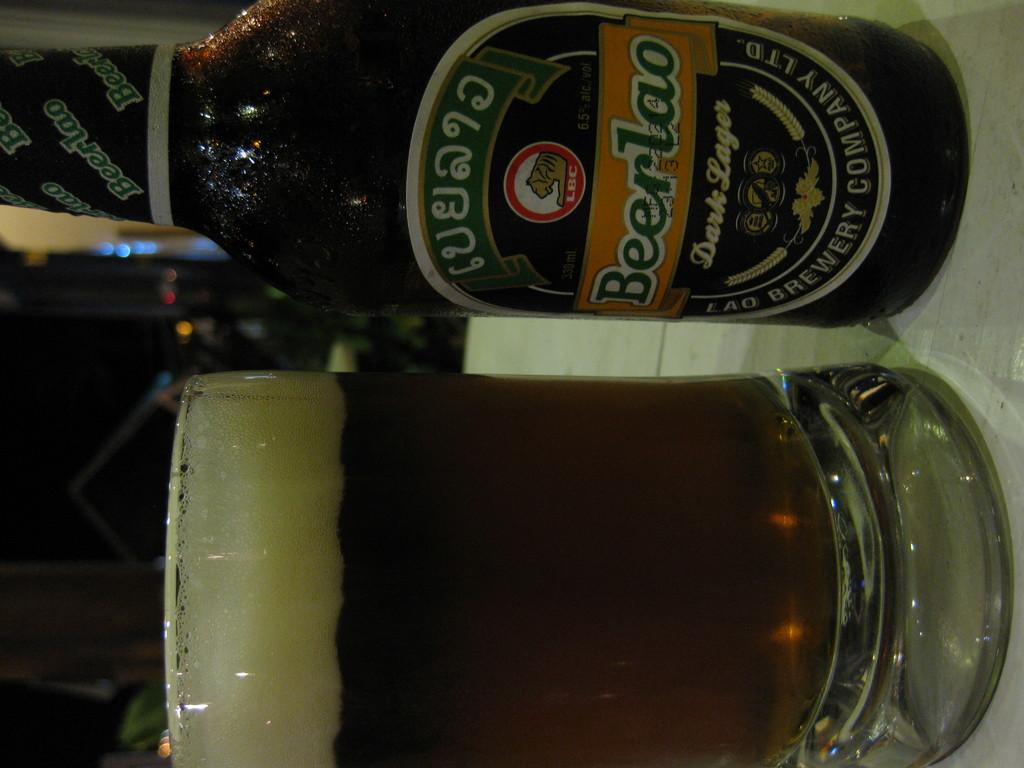What is the brand of the beer?
Make the answer very short. Beerlao. What shade of lager is this beer?
Ensure brevity in your answer.  Dark. 